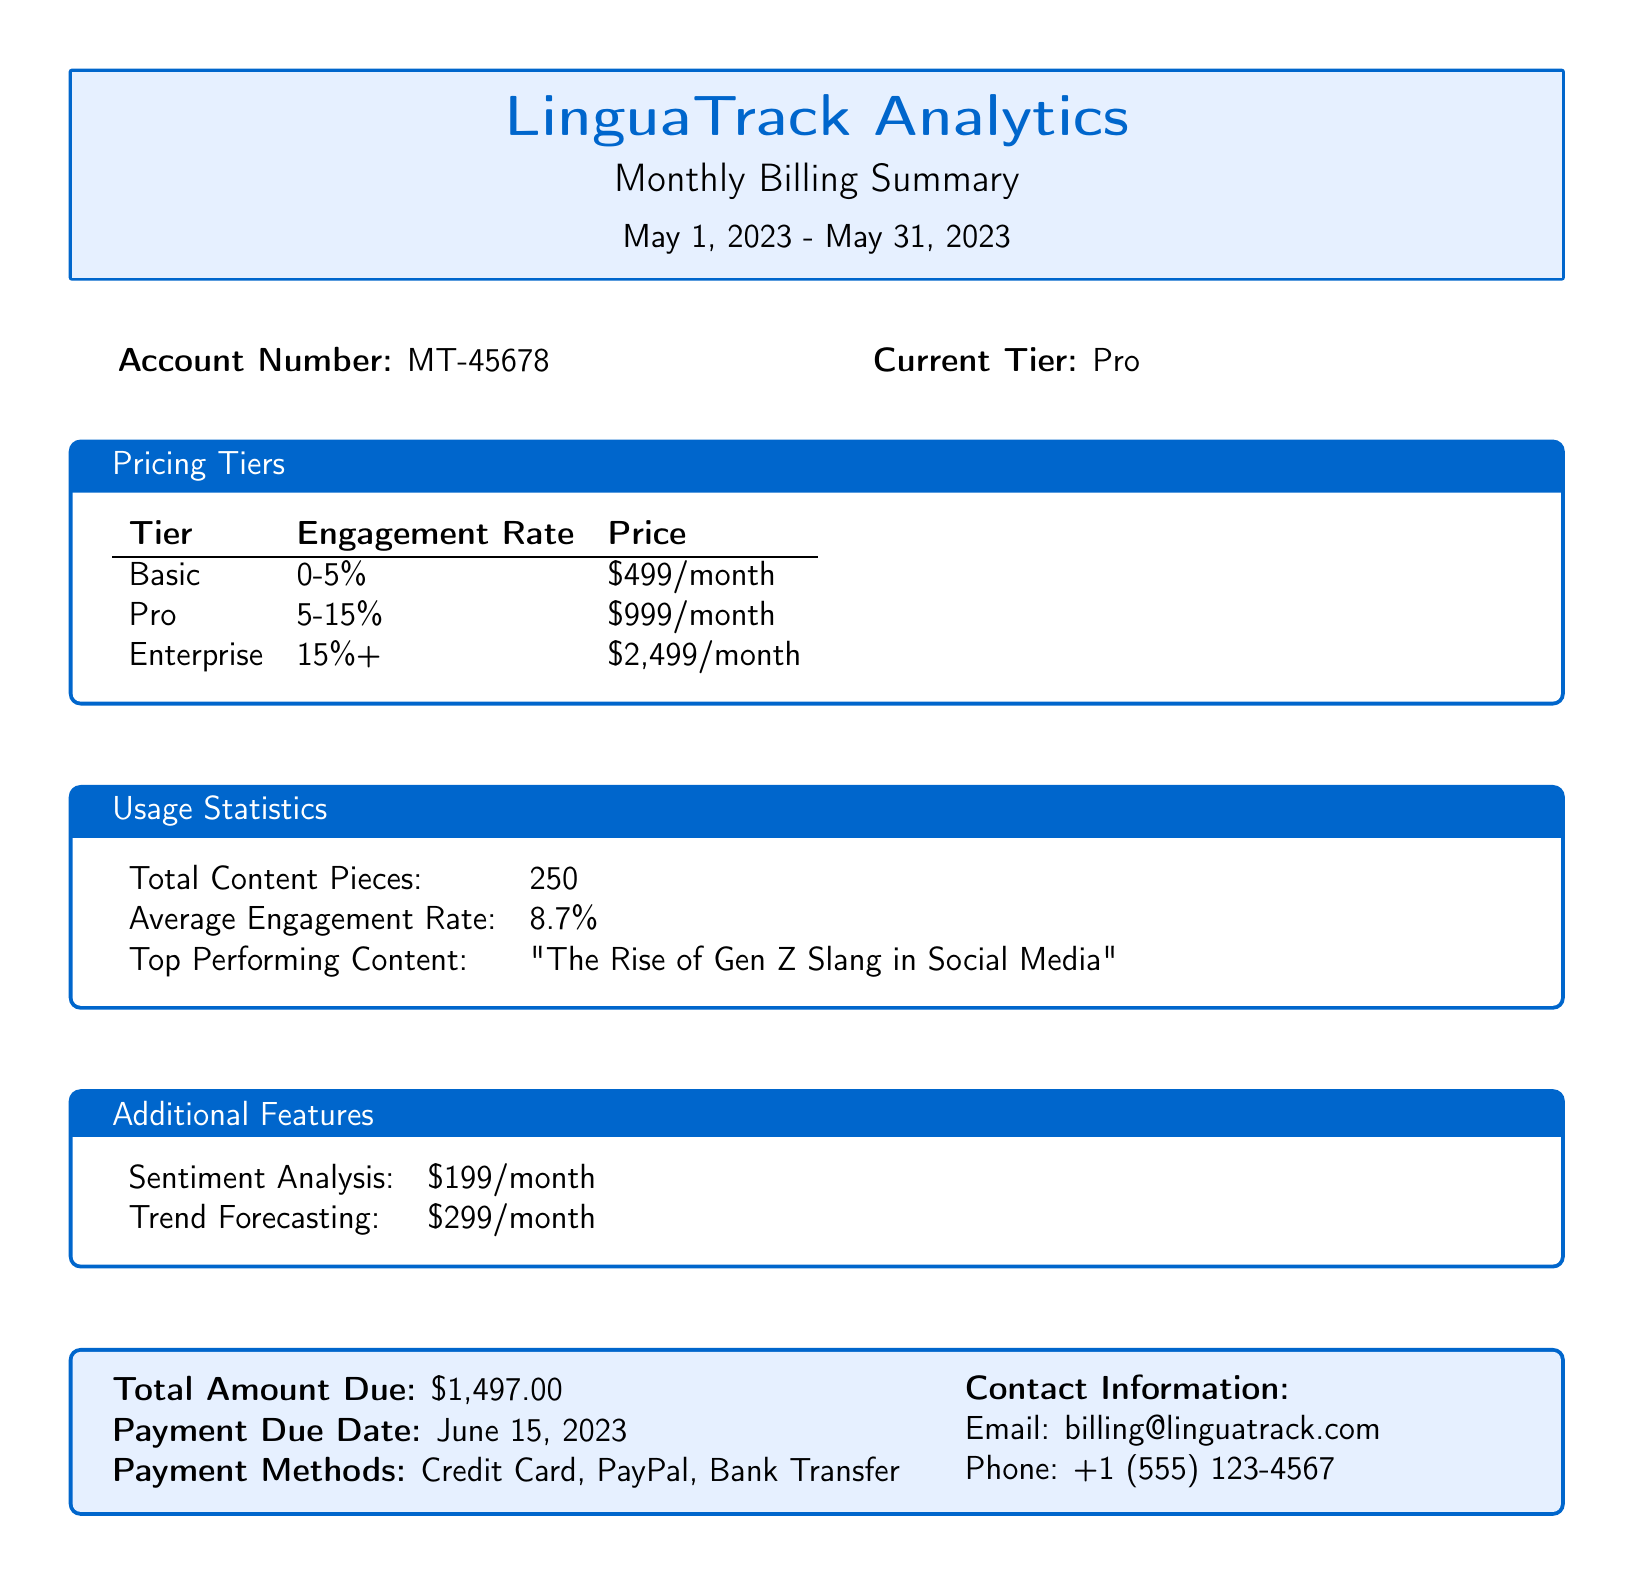What is the account number? The account number is a specific identifier for the account, which is provided in the document.
Answer: MT-45678 What is the current tier? The current tier is the pricing level the account is subscribed to, stated in the document.
Answer: Pro What is the average engagement rate? The average engagement rate reflects the performance of content and is specifically mentioned in the document.
Answer: 8.7% What is the price of the Enterprise tier? This price is provided in the pricing tiers section of the document, outlining costs associated with different engagement rates.
Answer: $2,499/month What is the total amount due? The total amount due accumulates all costs mentioned and is stated at the end of the document.
Answer: $1,497.00 When is the payment due date? The payment due date is the deadline for settling the total amount, as specified in the document.
Answer: June 15, 2023 What additional feature costs $299/month? This is a specific feature listed in the additional features section of the document, indicating its cost.
Answer: Trend Forecasting What is the title of the top-performing content? The top-performing content title showcases success metrics and is detailed in the usage statistics section of the document.
Answer: "The Rise of Gen Z Slang in Social Media" 